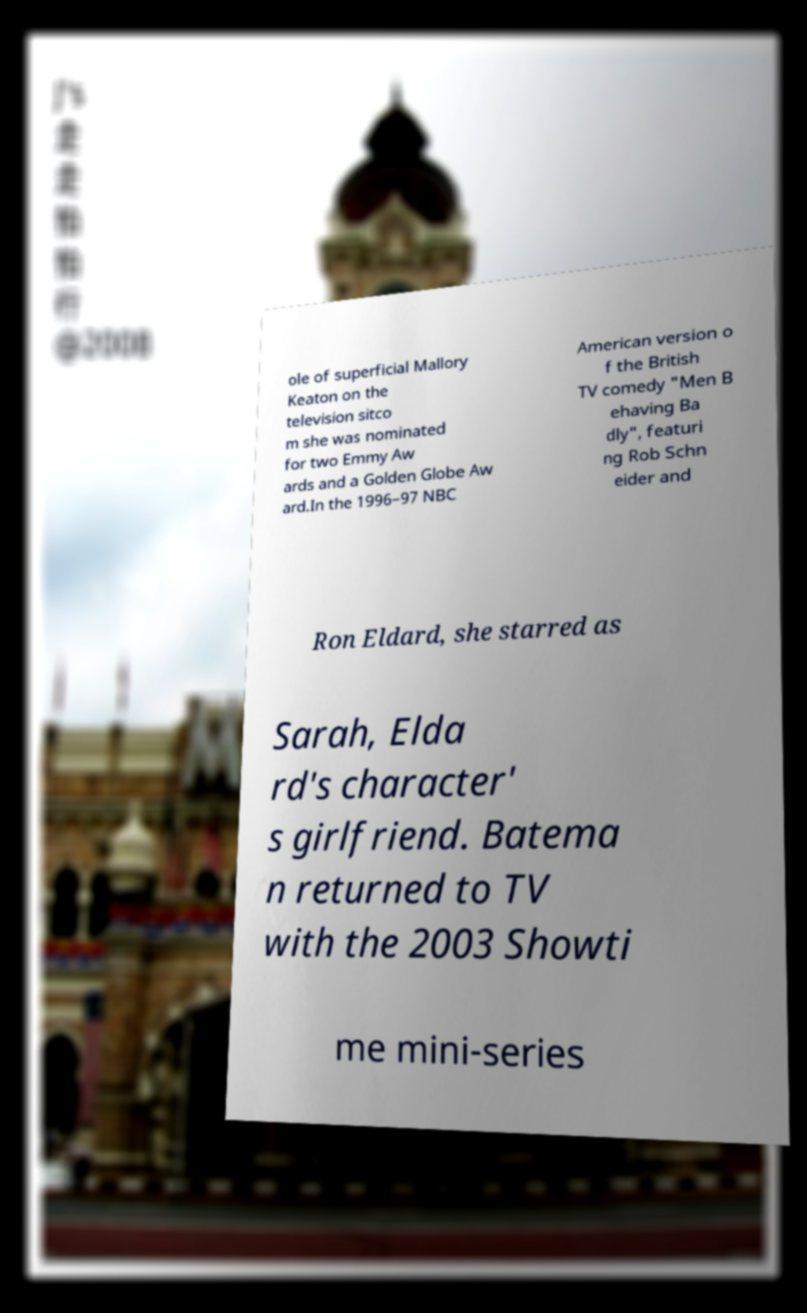Please read and relay the text visible in this image. What does it say? ole of superficial Mallory Keaton on the television sitco m she was nominated for two Emmy Aw ards and a Golden Globe Aw ard.In the 1996–97 NBC American version o f the British TV comedy "Men B ehaving Ba dly", featuri ng Rob Schn eider and Ron Eldard, she starred as Sarah, Elda rd's character' s girlfriend. Batema n returned to TV with the 2003 Showti me mini-series 